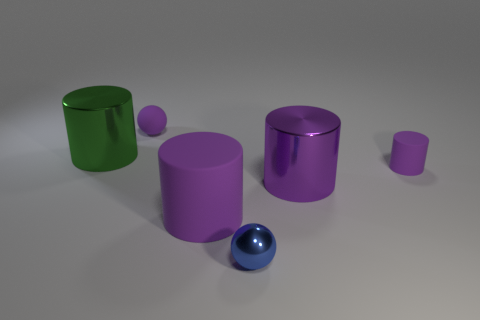How many things are both behind the purple metal cylinder and in front of the green cylinder?
Your answer should be compact. 1. There is a purple metal thing that is the same shape as the large green thing; what is its size?
Your response must be concise. Large. What number of tiny purple objects are made of the same material as the purple sphere?
Provide a short and direct response. 1. Is the number of large purple metallic cylinders to the right of the large purple metal cylinder less than the number of tiny purple cylinders?
Your response must be concise. Yes. What number of large purple cylinders are there?
Make the answer very short. 2. How many metal objects are the same color as the big rubber cylinder?
Give a very brief answer. 1. Is the shape of the big matte thing the same as the small blue metallic thing?
Offer a very short reply. No. There is a rubber thing on the left side of the rubber cylinder on the left side of the small blue object; what is its size?
Your answer should be compact. Small. Is there a brown matte sphere that has the same size as the purple shiny cylinder?
Offer a terse response. No. Does the metal cylinder that is right of the green shiny object have the same size as the sphere that is behind the purple metal cylinder?
Provide a short and direct response. No. 